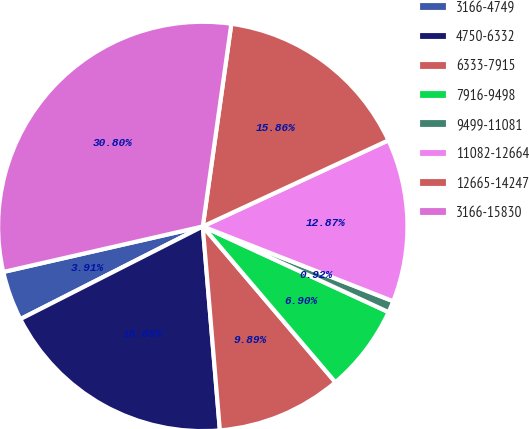Convert chart to OTSL. <chart><loc_0><loc_0><loc_500><loc_500><pie_chart><fcel>3166-4749<fcel>4750-6332<fcel>6333-7915<fcel>7916-9498<fcel>9499-11081<fcel>11082-12664<fcel>12665-14247<fcel>3166-15830<nl><fcel>3.91%<fcel>18.85%<fcel>9.89%<fcel>6.9%<fcel>0.92%<fcel>12.87%<fcel>15.86%<fcel>30.8%<nl></chart> 